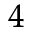<formula> <loc_0><loc_0><loc_500><loc_500>^ { 4 }</formula> 